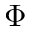<formula> <loc_0><loc_0><loc_500><loc_500>\Phi</formula> 